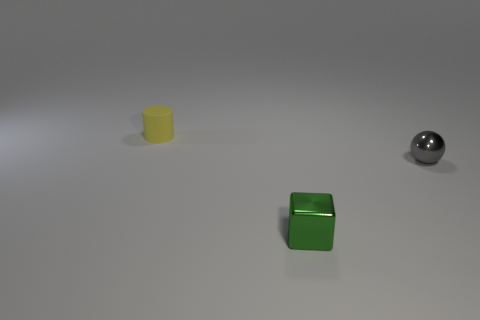Add 3 matte objects. How many objects exist? 6 Subtract all blocks. How many objects are left? 2 Subtract all green blocks. Subtract all yellow objects. How many objects are left? 1 Add 2 yellow things. How many yellow things are left? 3 Add 3 rubber objects. How many rubber objects exist? 4 Subtract 0 brown cylinders. How many objects are left? 3 